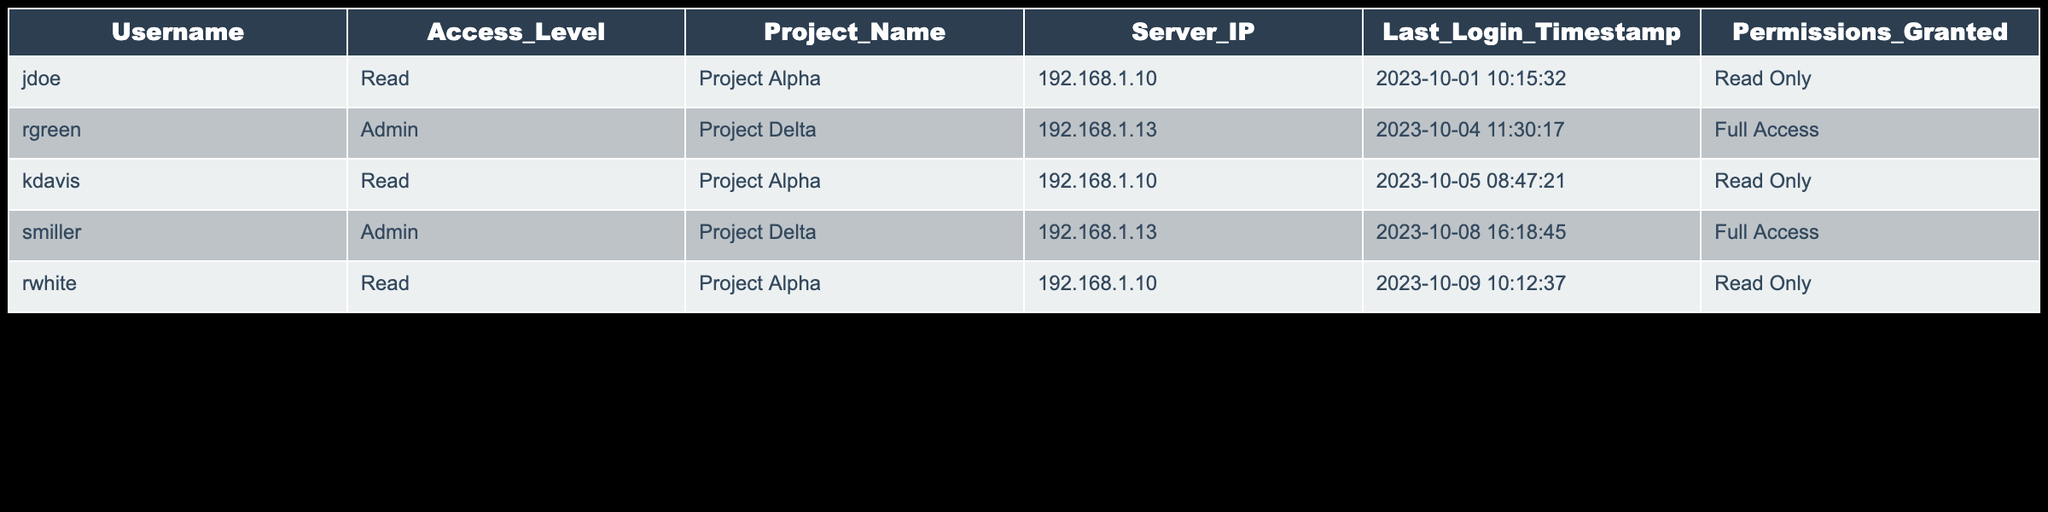What is the username of the admin user for Project Delta? The admin users listed for Project Delta are rgreen and smiller. They both have the admin access level for the same project, but the question specifically asks for one username. According to the table, either can be a valid answer; however, I will select the first one mentioned.
Answer: rgreen How many users have Read access for Project Alpha? Scanning the table, there are three entries for users who have Read access for Project Alpha: jdoe, kdavis, and rwhite.
Answer: 3 Is there any user who has full access permissions on Project Alpha? Checking the table, I see that the Permissions_Granted for all entries under Project Alpha are "Read Only." Hence, there are no users with full access permissions on this project.
Answer: No What was the last login timestamp for the user with username 'smiller'? Referring to the table, the Last_Login_Timestamp for smiller is "2023-10-08 16:18:45." This information is available in the respective row for that user.
Answer: 2023-10-08 16:18:45 Which project has the highest access level granted to users? Analyzing the table, we note that Project Delta has users with Admin access level (rgreen and smiller), whereas Project Alpha only has users with Read access level. Therefore, Project Delta has the highest access level granted.
Answer: Project Delta How many unique usernames are there across both projects? By listing the usernames from the table, we find the unique users: jdoe, rgreen, kdavis, smiller, and rwhite. This gives us five distinct usernames.
Answer: 5 Did any user log in to the server at the same IP address for different projects? In the table, we see that both jdoe and kdavis, as well as rwhite, logged into the server with the IP address 192.168.1.10 for Project Alpha. No users are shown logging at the same IP address for a different project. Thus, the answer is based on the unique association of users and IPs.
Answer: No What is the difference in the number of users with Admin access versus Read access? From the table, there are two users with Admin access (rgreen and smiller) and three users with Read access (jdoe, kdavis, rwhite). Therefore, to find the difference: 3 (Read) - 2 (Admin) = 1.
Answer: 1 